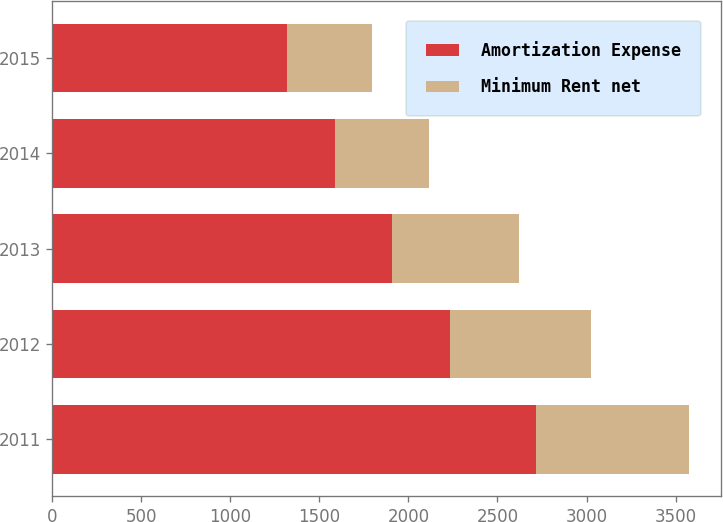Convert chart. <chart><loc_0><loc_0><loc_500><loc_500><stacked_bar_chart><ecel><fcel>2011<fcel>2012<fcel>2013<fcel>2014<fcel>2015<nl><fcel>Amortization Expense<fcel>2715<fcel>2233<fcel>1907<fcel>1585<fcel>1319<nl><fcel>Minimum Rent net<fcel>859<fcel>793<fcel>715<fcel>530<fcel>474<nl></chart> 